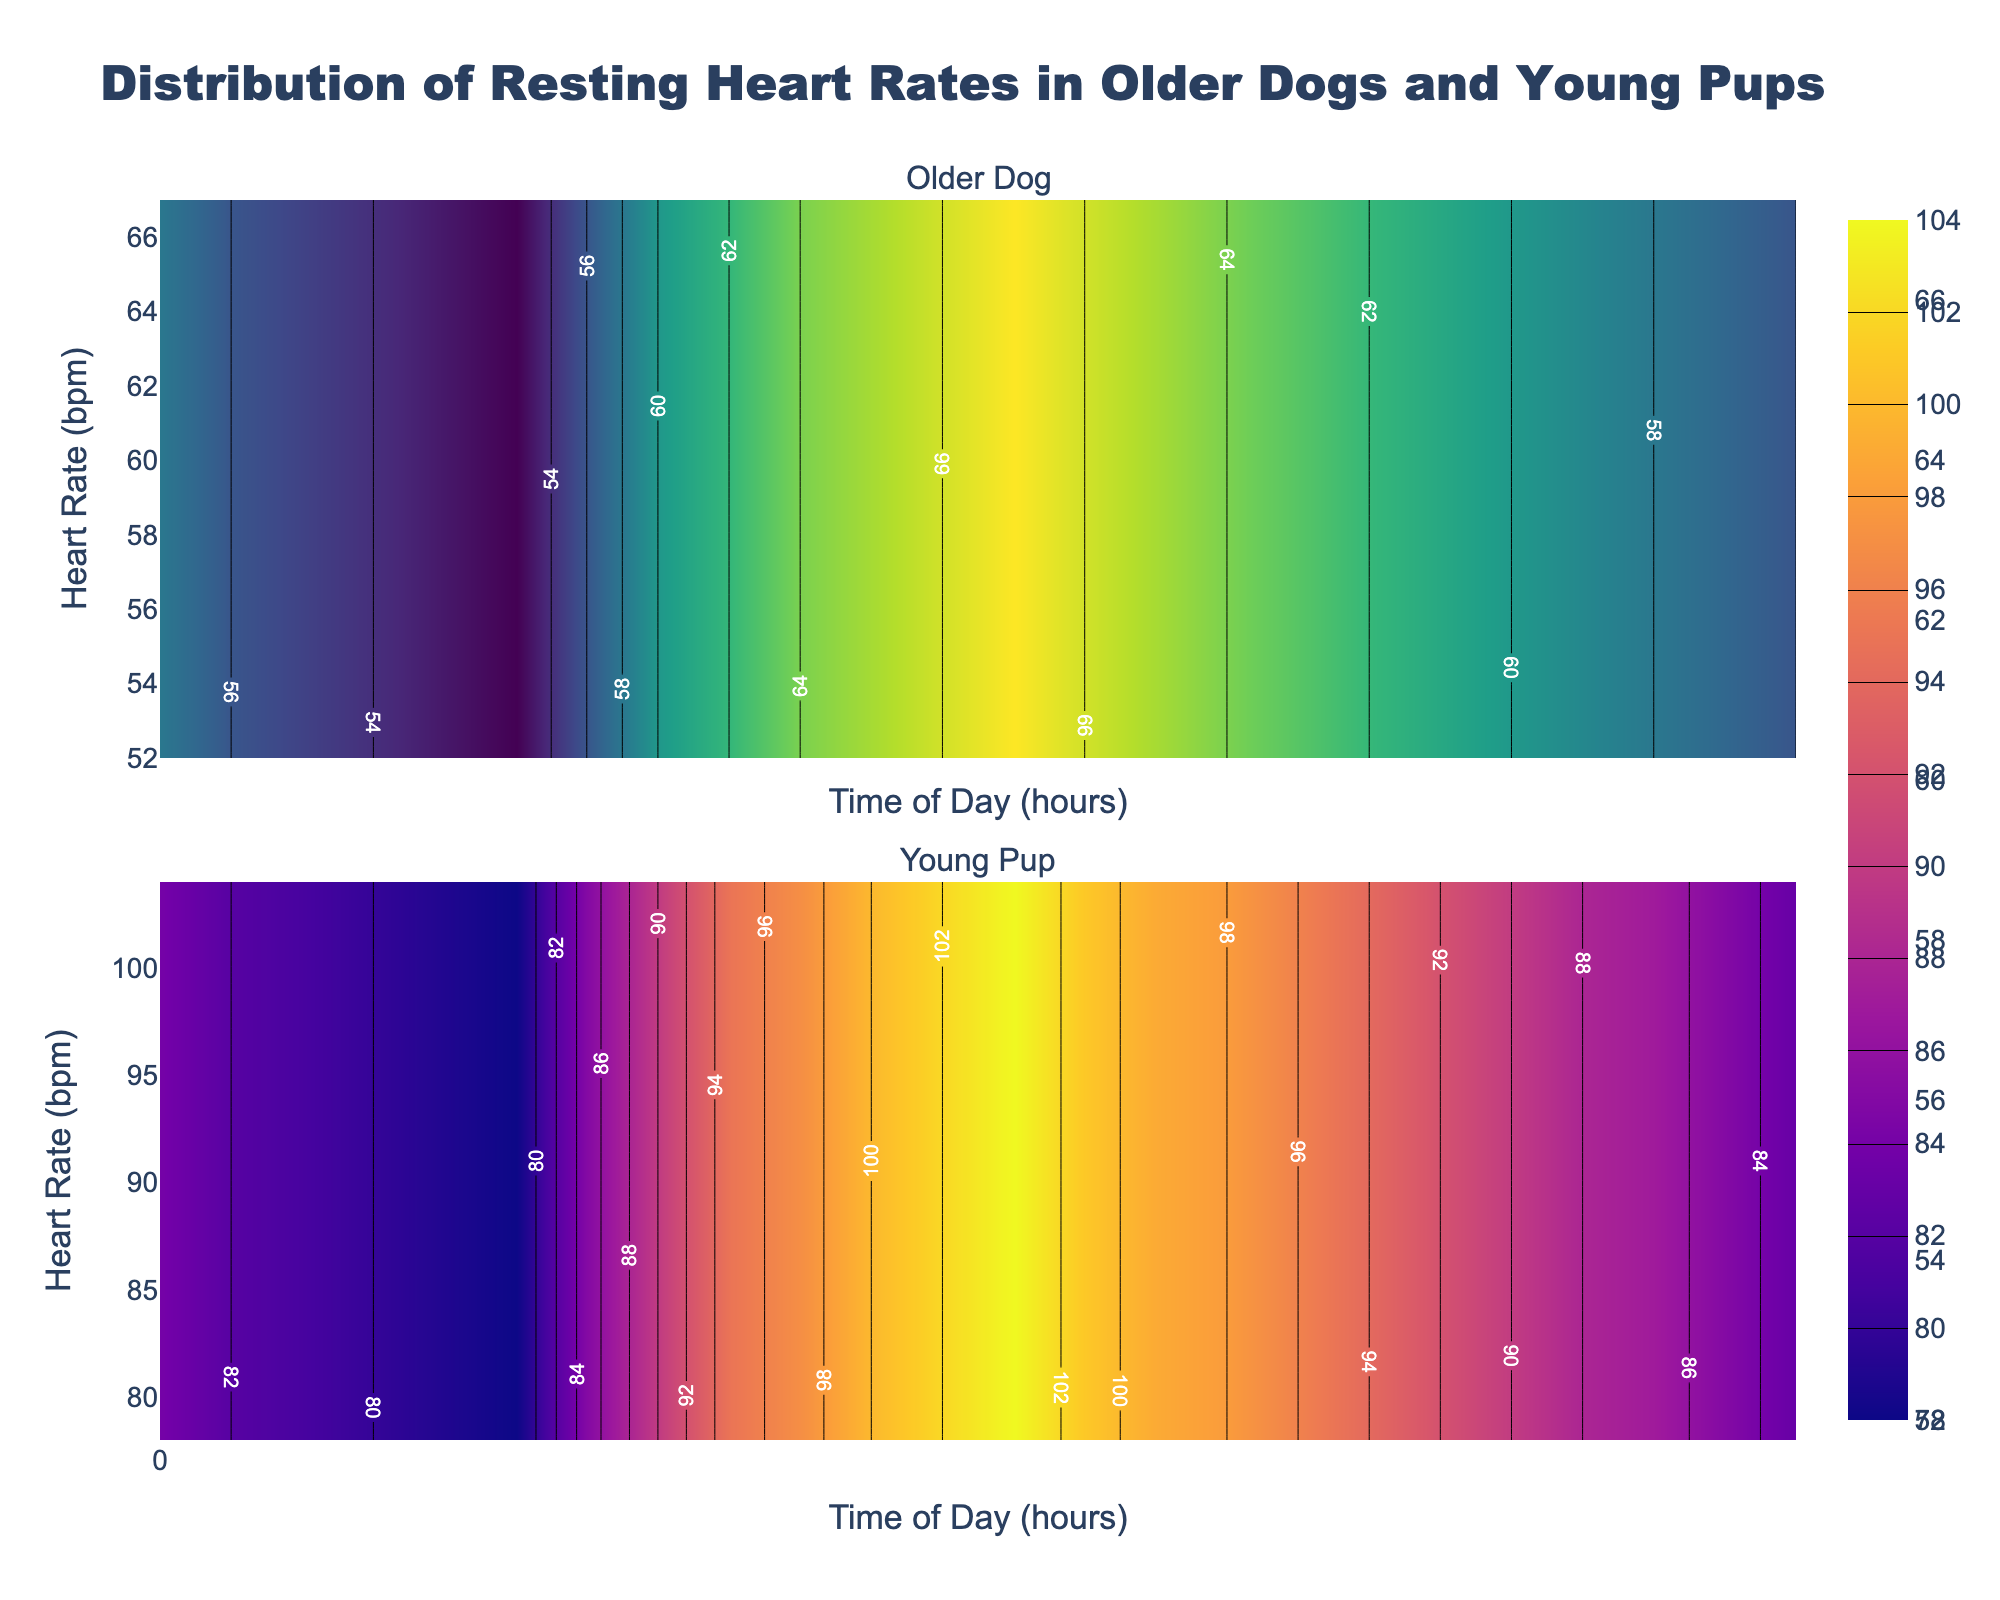What is the time range displayed on the x-axis? The x-axis represents the time of day, starting from 00:00 (midnight) to 23:00 (11 PM). The plot shows the distribution of heart rates across these hours.
Answer: 00:00 to 23:00 What are the color scales used for the older dog and young pup? The color scale for the older dog subplot is 'Viridis', typically ranging from dark blue to yellowish-green. The young pup subplot uses the 'Plasma' color scale, which usually ranges from purple to yellow.
Answer: Viridis and Plasma Around what time of day does the young pup have the highest heart rate? The contour plot for the young pup shows the highest heart rate occurs around midday. Specifically, between 12:00 and 13:00, the heart rate peaks.
Answer: Around 12:00-13:00 Compare the general pattern of heart rates between older dogs and young pups throughout the day. Observing the contour plots shows that the older dog's heart rate steadily increases until around noon, then slightly decreases towards the evening. In contrast, the young pup’s heart rate increases more sharply in the morning and maintains higher levels throughout the day, particularly peaking around noon, before slightly declining in the evening.
Answer: Young pups have more pronounced and higher heart rate peaks compared to older dogs How does the heart rate of older dogs change from morning to evening? From morning (06:00) to evening (18:00), the older dog's heart rate increases from about 56 bpm to around 61 bpm, showing a gradual rise throughout the day.
Answer: Increases gradually from 56 bpm to 61 bpm Which age group has a more stable heart rate throughout the day? The older dog's heart rate shows a more stable pattern, with gradual changes throughout the day. In contrast, the young pup's heart rate exhibits larger fluctuations, indicating less stability.
Answer: Older dogs Which heart rate value is common between both older dogs and young pups? Observing the contour plots, the heart rate of 85 bpm is a value seen for both older dogs (early morning and late evening) and young pups (early morning and late evening).
Answer: 85 bpm What is the maximum heart rate recorded for the older dog? The contour plot for the older dog indicates the highest heart rate is around 67 bpm, which occurs around midday.
Answer: 67 bpm During which time period do resting heart rates for older dogs remain below 60 bpm? From midnight (00:00) to early morning (06:00) and late evening (19:00) onward, the older dog's heart rate stays below 60 bpm, as indicated by the contour plot.
Answer: 00:00 to 06:00 and after 19:00 How is the detailed heart rate pattern different in the early morning for both age groups? In the early morning (00:00 to 06:00), older dogs have a steadily high heart rate around 56-58 bpm, gently decreasing to 52 bpm near dawn. Young pups start higher at 84 bpm and decrease more gradually to around 78 bpm by dawn.
Answer: Older dogs have steady and minor decreases; young pups have higher rates that decline gradually 